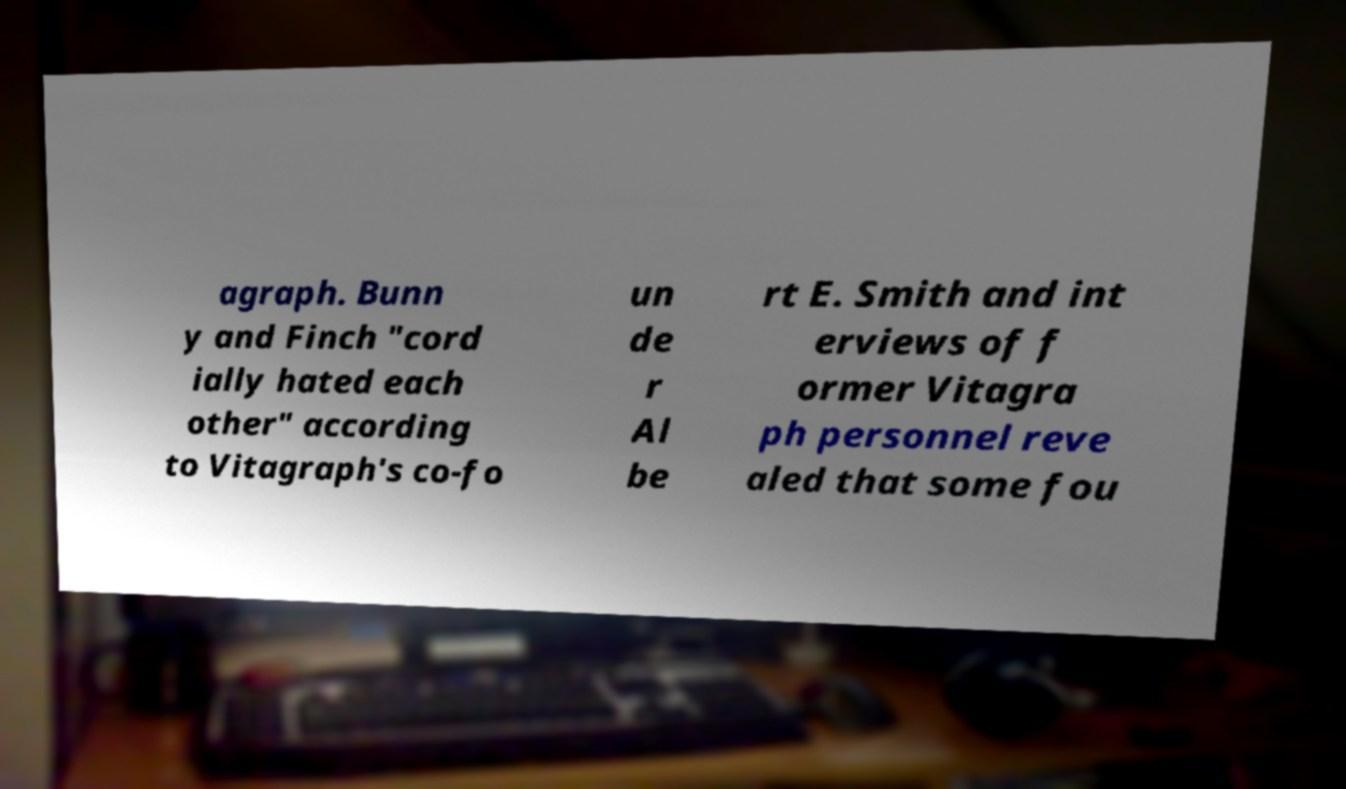Please identify and transcribe the text found in this image. agraph. Bunn y and Finch "cord ially hated each other" according to Vitagraph's co-fo un de r Al be rt E. Smith and int erviews of f ormer Vitagra ph personnel reve aled that some fou 